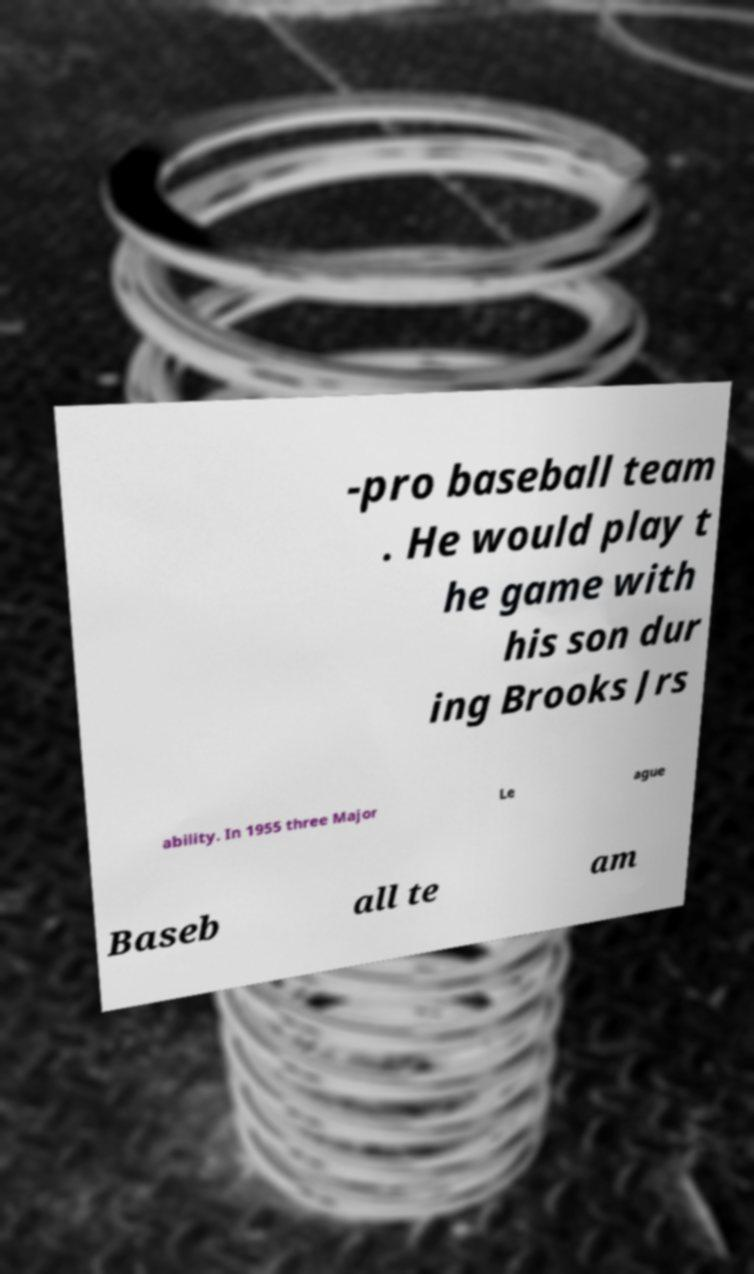Can you read and provide the text displayed in the image?This photo seems to have some interesting text. Can you extract and type it out for me? -pro baseball team . He would play t he game with his son dur ing Brooks Jrs ability. In 1955 three Major Le ague Baseb all te am 